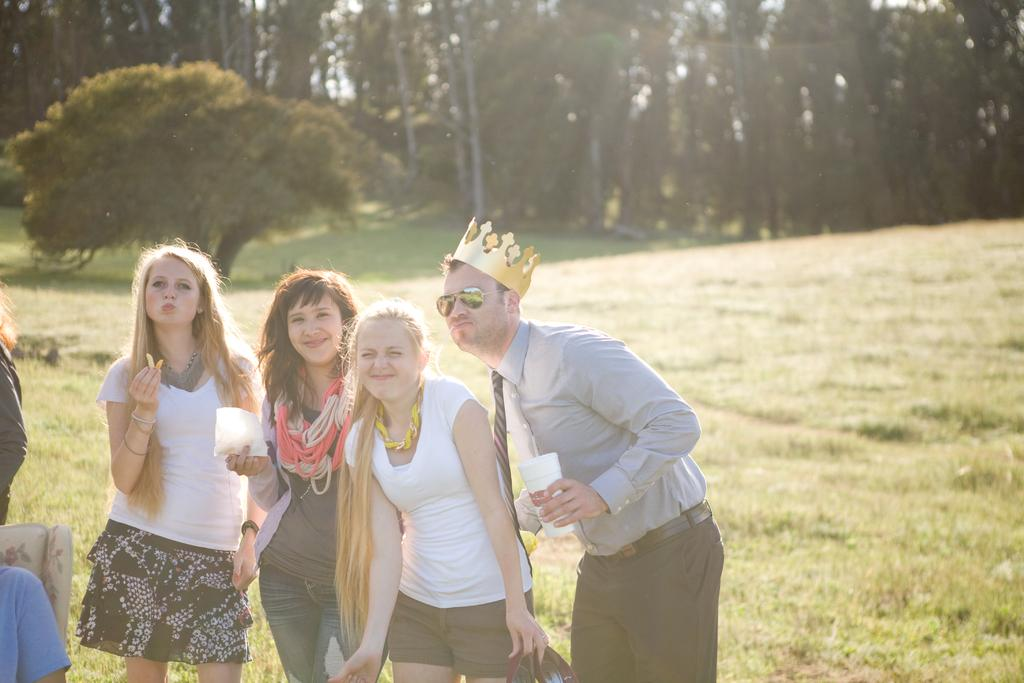How many people are in the image? There are four persons in the image. What is the ground like where the persons are standing? The persons are standing on a greenery ground. What are the persons holding in their hands? The persons are holding an object in their hands. What can be seen in the background of the image? There are trees in the background of the image. What type of flame can be seen coming from the object held by the persons in the image? There is no flame present in the image; the persons are holding an object, but its nature is not specified. 